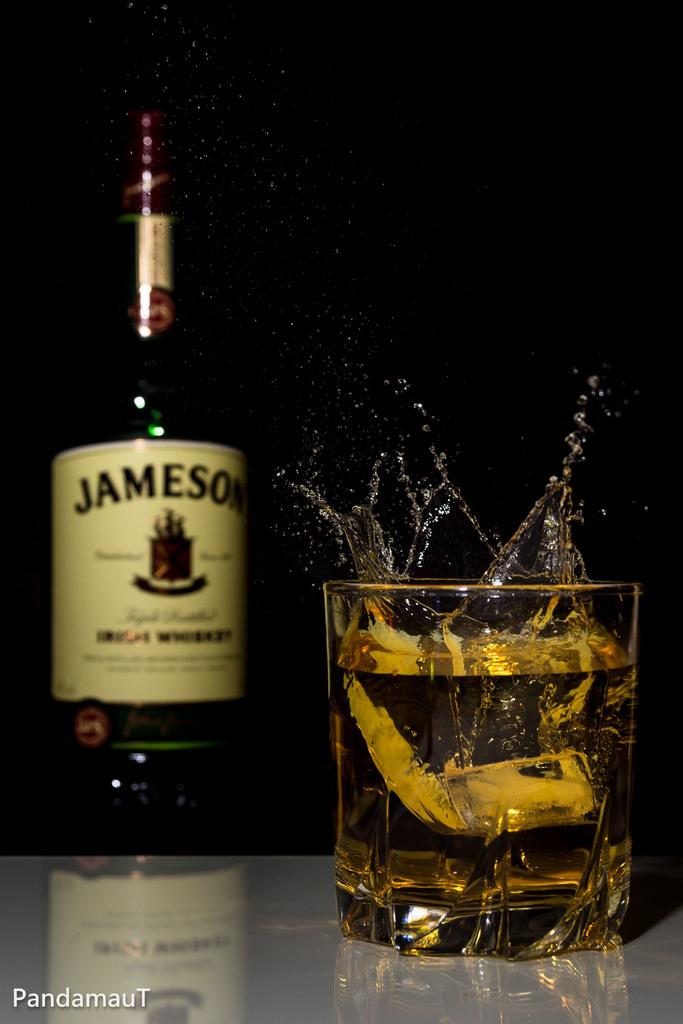What is the name on the bottle?
Make the answer very short. Jameson. 